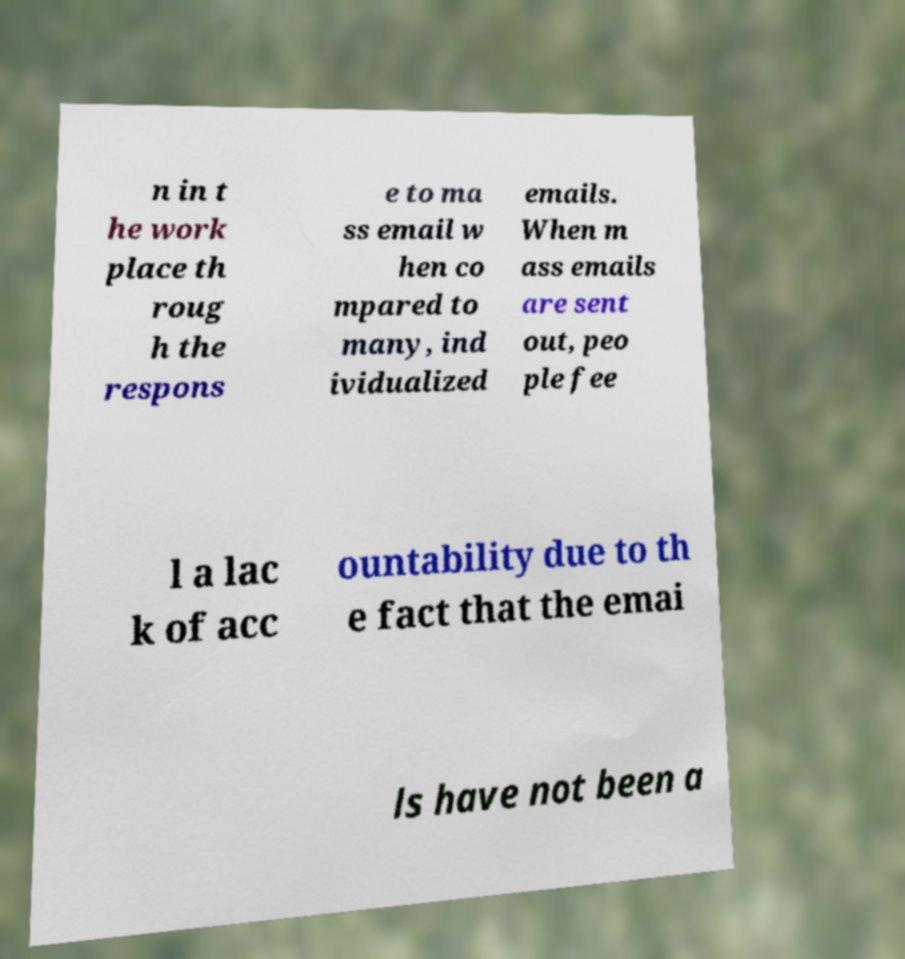Can you accurately transcribe the text from the provided image for me? n in t he work place th roug h the respons e to ma ss email w hen co mpared to many, ind ividualized emails. When m ass emails are sent out, peo ple fee l a lac k of acc ountability due to th e fact that the emai ls have not been a 